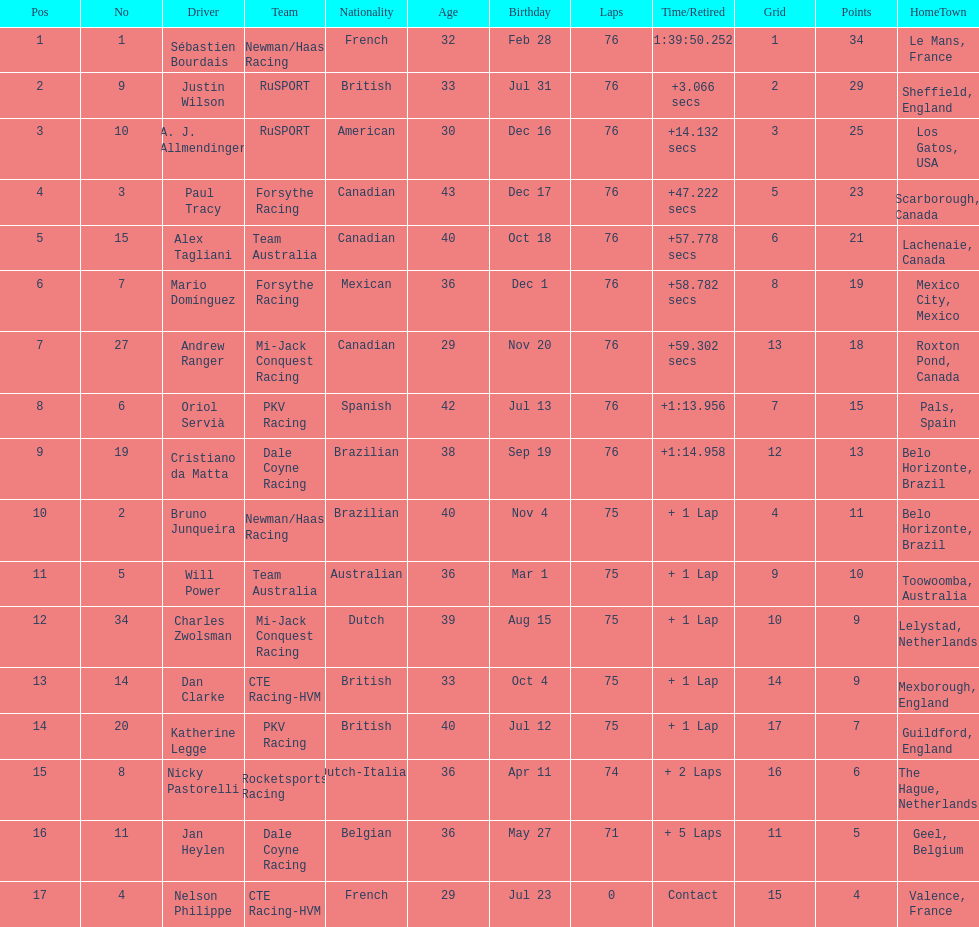What driver earned the most points? Sebastien Bourdais. Would you mind parsing the complete table? {'header': ['Pos', 'No', 'Driver', 'Team', 'Nationality', 'Age', 'Birthday', 'Laps', 'Time/Retired', 'Grid', 'Points', 'HomeTown'], 'rows': [['1', '1', 'Sébastien Bourdais', 'Newman/Haas Racing', 'French', '32', 'Feb 28', '76', '1:39:50.252', '1', '34', 'Le Mans, France'], ['2', '9', 'Justin Wilson', 'RuSPORT', 'British', '33', 'Jul 31', '76', '+3.066 secs', '2', '29', 'Sheffield, England'], ['3', '10', 'A. J. Allmendinger', 'RuSPORT', 'American', '30', 'Dec 16', '76', '+14.132 secs', '3', '25', 'Los Gatos, USA'], ['4', '3', 'Paul Tracy', 'Forsythe Racing', 'Canadian', '43', 'Dec 17', '76', '+47.222 secs', '5', '23', 'Scarborough, Canada'], ['5', '15', 'Alex Tagliani', 'Team Australia', 'Canadian', '40', 'Oct 18', '76', '+57.778 secs', '6', '21', 'Lachenaie, Canada'], ['6', '7', 'Mario Domínguez', 'Forsythe Racing', 'Mexican', '36', 'Dec 1', '76', '+58.782 secs', '8', '19', 'Mexico City, Mexico'], ['7', '27', 'Andrew Ranger', 'Mi-Jack Conquest Racing', 'Canadian', '29', 'Nov 20', '76', '+59.302 secs', '13', '18', 'Roxton Pond, Canada'], ['8', '6', 'Oriol Servià', 'PKV Racing', 'Spanish', '42', 'Jul 13', '76', '+1:13.956', '7', '15', 'Pals, Spain'], ['9', '19', 'Cristiano da Matta', 'Dale Coyne Racing', 'Brazilian', '38', 'Sep 19', '76', '+1:14.958', '12', '13', 'Belo Horizonte, Brazil'], ['10', '2', 'Bruno Junqueira', 'Newman/Haas Racing', 'Brazilian', '40', 'Nov 4', '75', '+ 1 Lap', '4', '11', 'Belo Horizonte, Brazil'], ['11', '5', 'Will Power', 'Team Australia', 'Australian', '36', 'Mar 1', '75', '+ 1 Lap', '9', '10', 'Toowoomba, Australia'], ['12', '34', 'Charles Zwolsman', 'Mi-Jack Conquest Racing', 'Dutch', '39', 'Aug 15', '75', '+ 1 Lap', '10', '9', 'Lelystad, Netherlands'], ['13', '14', 'Dan Clarke', 'CTE Racing-HVM', 'British', '33', 'Oct 4', '75', '+ 1 Lap', '14', '9', 'Mexborough, England'], ['14', '20', 'Katherine Legge', 'PKV Racing', 'British', '40', 'Jul 12', '75', '+ 1 Lap', '17', '7', 'Guildford, England'], ['15', '8', 'Nicky Pastorelli', 'Rocketsports Racing', 'Dutch-Italian', '36', 'Apr 11', '74', '+ 2 Laps', '16', '6', 'The Hague, Netherlands'], ['16', '11', 'Jan Heylen', 'Dale Coyne Racing', 'Belgian', '36', 'May 27', '71', '+ 5 Laps', '11', '5', 'Geel, Belgium'], ['17', '4', 'Nelson Philippe', 'CTE Racing-HVM', 'French', '29', 'Jul 23', '0', 'Contact', '15', '4', 'Valence, France']]} 